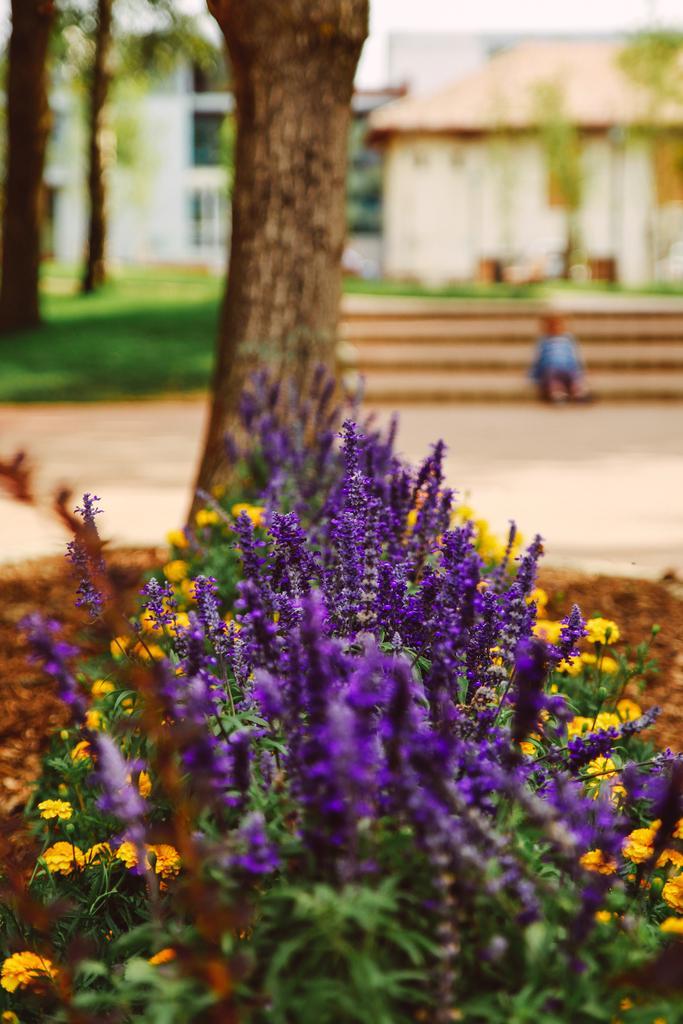In one or two sentences, can you explain what this image depicts? In this image we can see two houses, in front of the white building some grass is there. So many trees and some plants are there. In front of the house in staircase small boy is sitting. One road is there. 